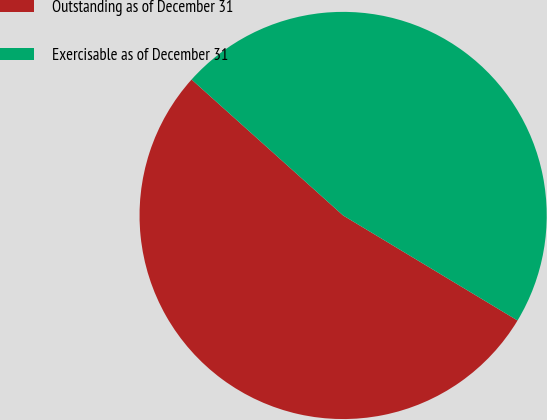<chart> <loc_0><loc_0><loc_500><loc_500><pie_chart><fcel>Outstanding as of December 31<fcel>Exercisable as of December 31<nl><fcel>53.01%<fcel>46.99%<nl></chart> 